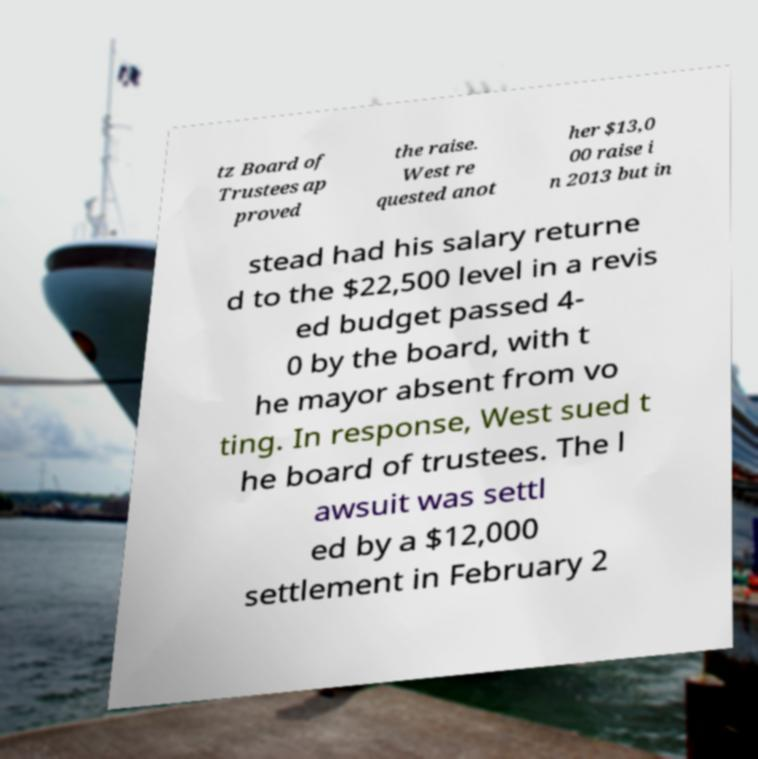For documentation purposes, I need the text within this image transcribed. Could you provide that? tz Board of Trustees ap proved the raise. West re quested anot her $13,0 00 raise i n 2013 but in stead had his salary returne d to the $22,500 level in a revis ed budget passed 4- 0 by the board, with t he mayor absent from vo ting. In response, West sued t he board of trustees. The l awsuit was settl ed by a $12,000 settlement in February 2 